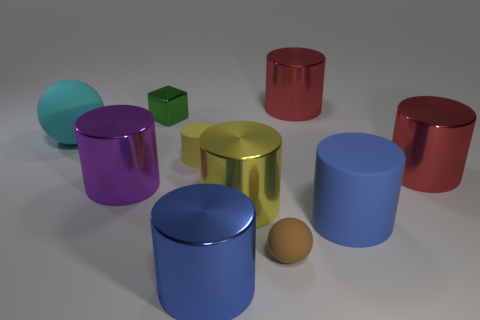How many cylinders are there in total, and can you describe their colors? There are a total of seven cylinders. Starting from the left, we have one in turquoise, a purple one, a small green one, a large yellow one, a large navy blue one, and finally two red cylinders, one being smaller than the other. 